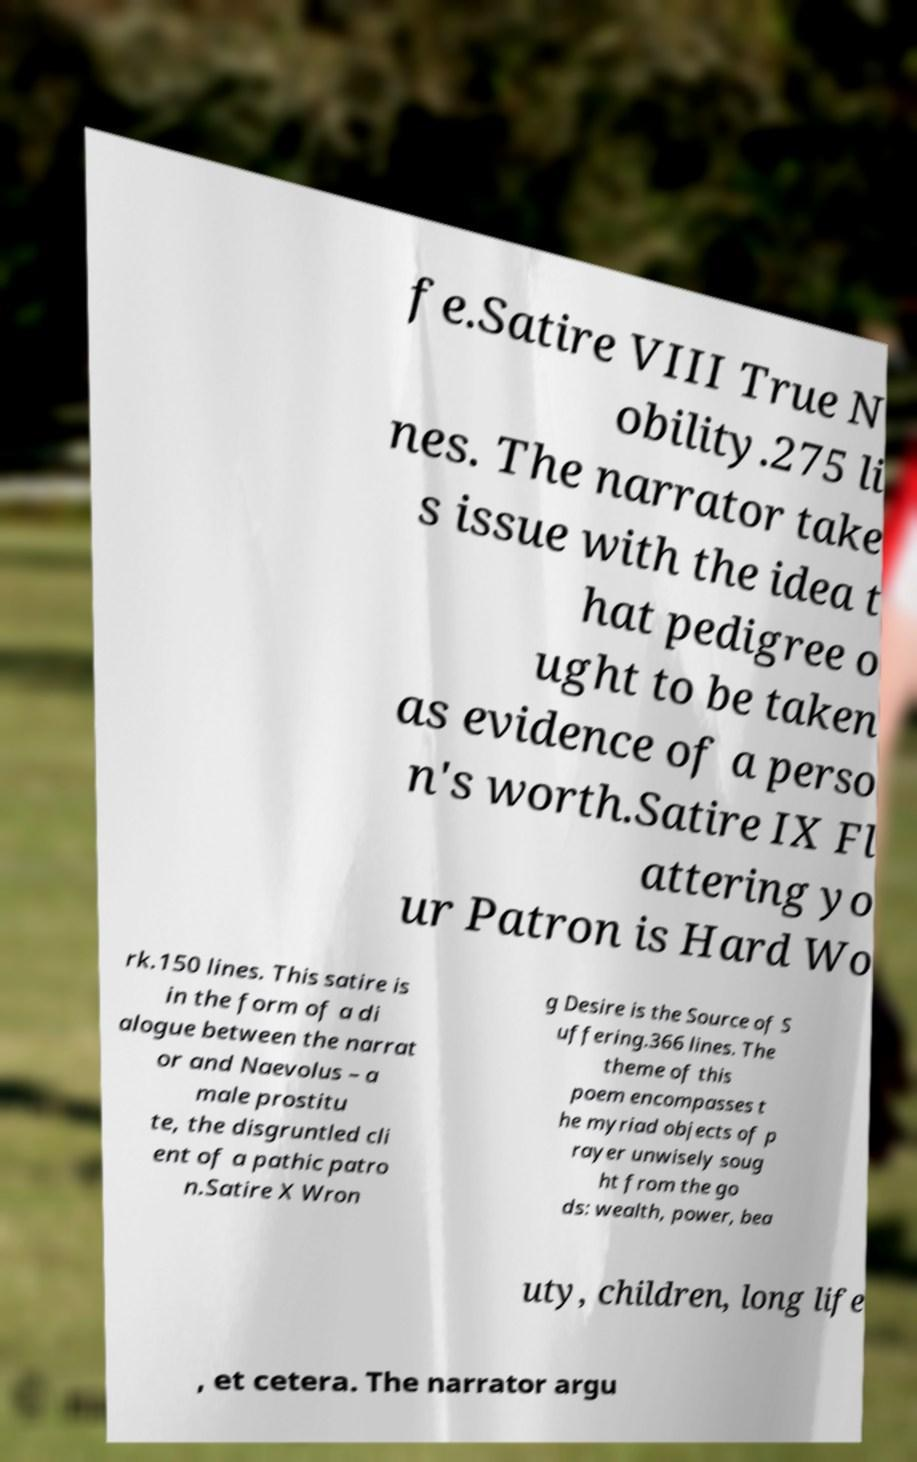For documentation purposes, I need the text within this image transcribed. Could you provide that? fe.Satire VIII True N obility.275 li nes. The narrator take s issue with the idea t hat pedigree o ught to be taken as evidence of a perso n's worth.Satire IX Fl attering yo ur Patron is Hard Wo rk.150 lines. This satire is in the form of a di alogue between the narrat or and Naevolus – a male prostitu te, the disgruntled cli ent of a pathic patro n.Satire X Wron g Desire is the Source of S uffering.366 lines. The theme of this poem encompasses t he myriad objects of p rayer unwisely soug ht from the go ds: wealth, power, bea uty, children, long life , et cetera. The narrator argu 